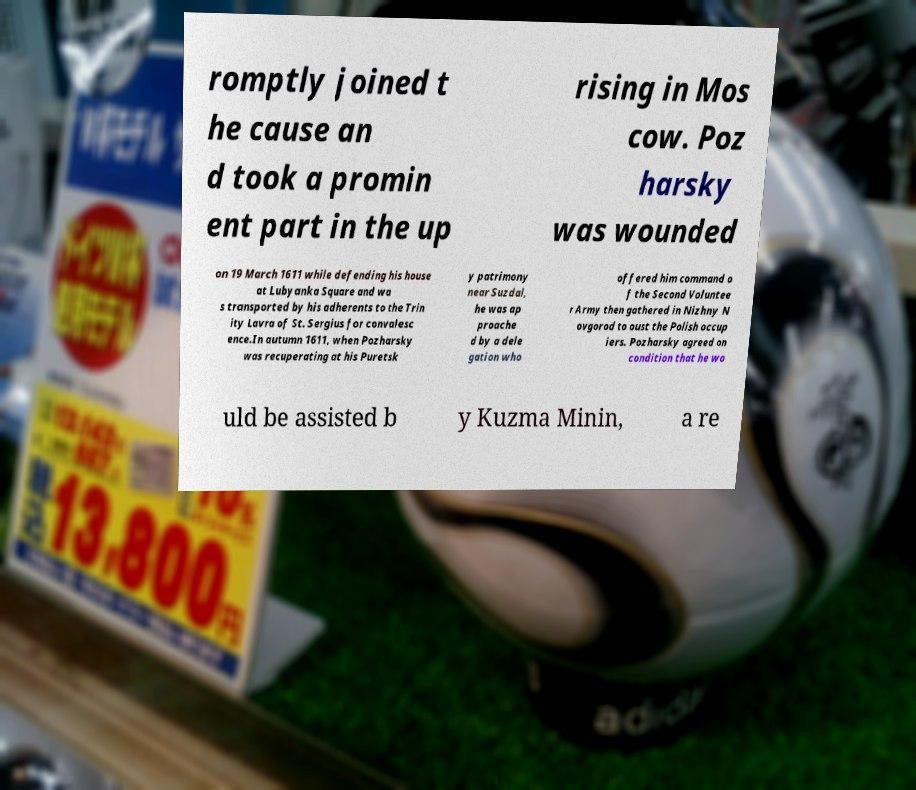Please read and relay the text visible in this image. What does it say? romptly joined t he cause an d took a promin ent part in the up rising in Mos cow. Poz harsky was wounded on 19 March 1611 while defending his house at Lubyanka Square and wa s transported by his adherents to the Trin ity Lavra of St. Sergius for convalesc ence.In autumn 1611, when Pozharsky was recuperating at his Puretsk y patrimony near Suzdal, he was ap proache d by a dele gation who offered him command o f the Second Voluntee r Army then gathered in Nizhny N ovgorod to oust the Polish occup iers. Pozharsky agreed on condition that he wo uld be assisted b y Kuzma Minin, a re 